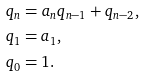Convert formula to latex. <formula><loc_0><loc_0><loc_500><loc_500>& q _ { n } = a _ { n } q _ { n - 1 } + q _ { n - 2 } , \\ & q _ { 1 } = a _ { 1 } , \\ & q _ { 0 } = 1 .</formula> 